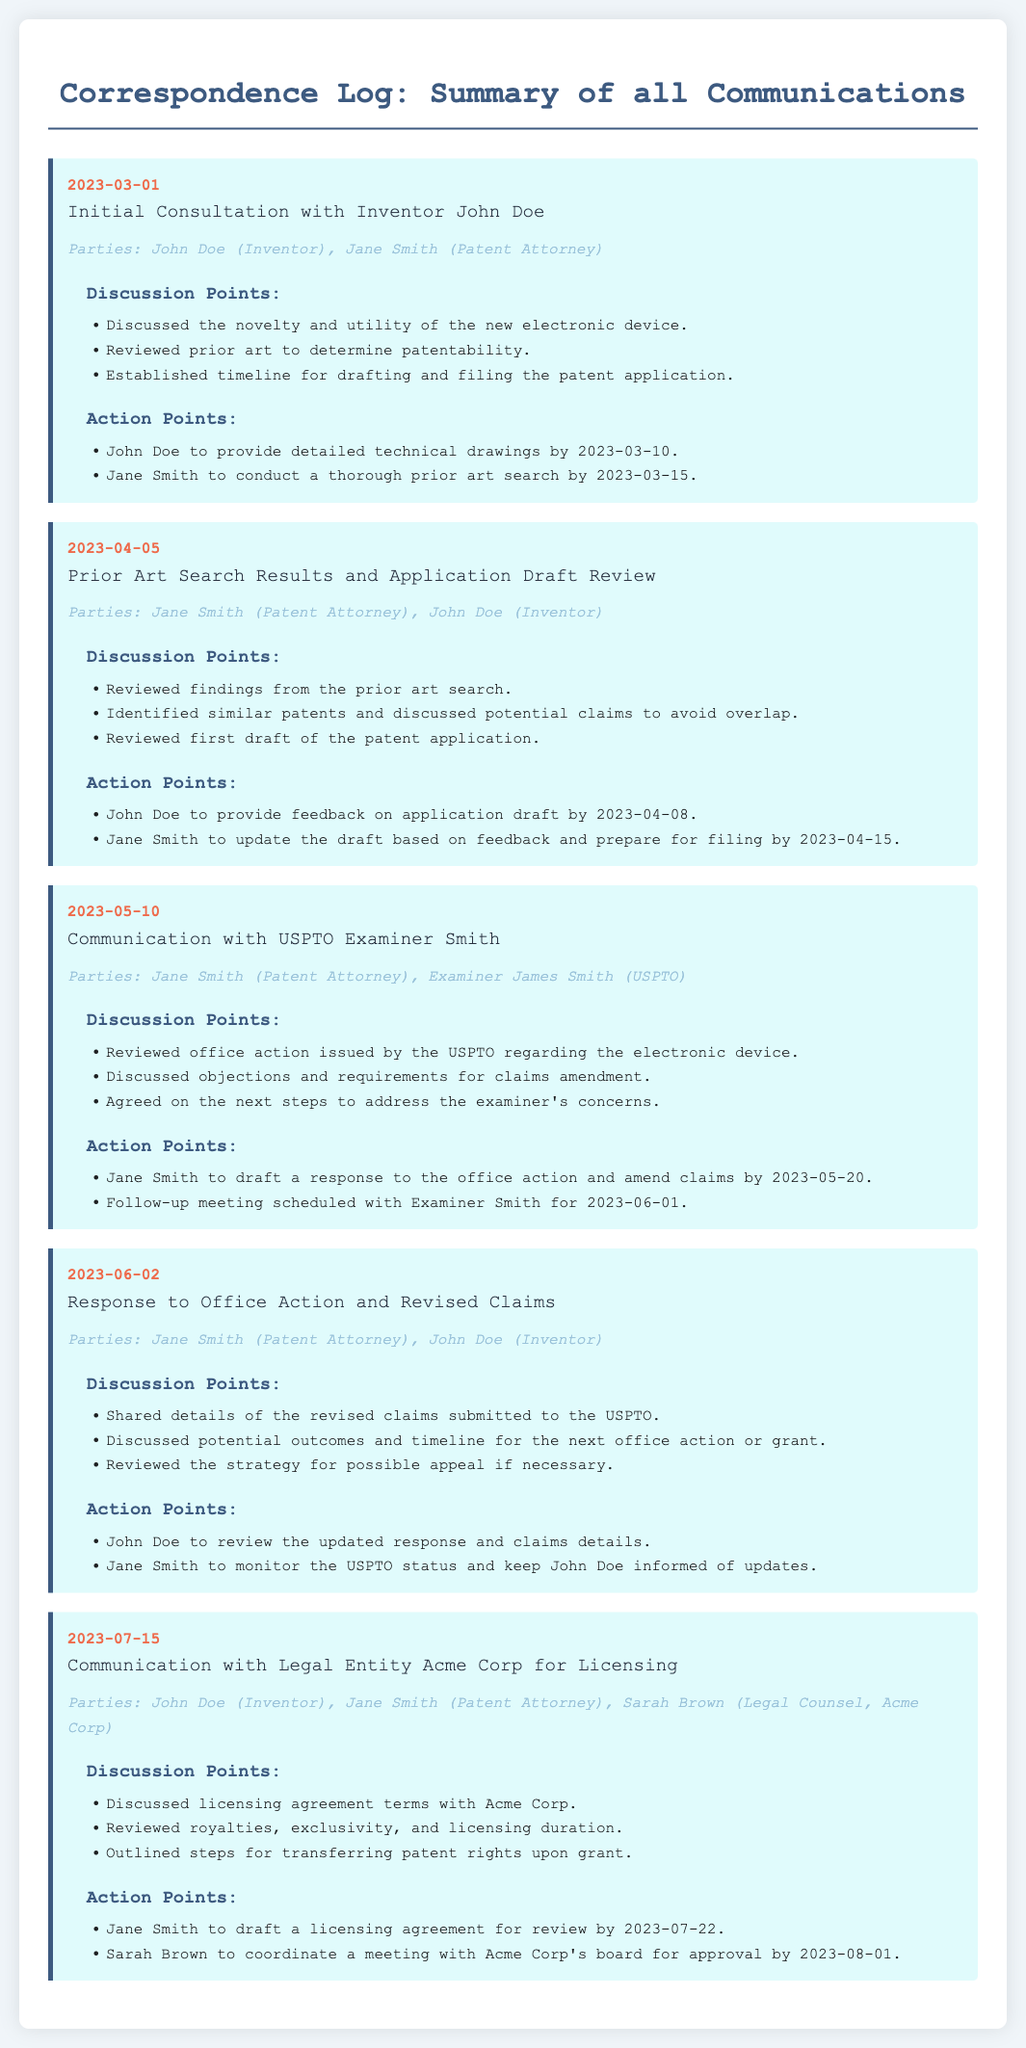what is the date of the initial consultation? The initial consultation with inventor John Doe took place on March 1, 2023.
Answer: March 1, 2023 who is the patent attorney associated with John Doe? Jane Smith is the patent attorney who communicated with inventor John Doe.
Answer: Jane Smith what was discussed during the meeting on April 5, 2023? During the April 5, 2023 meeting, the findings from the prior art search and the first draft of the patent application were discussed.
Answer: Prior art search results what action is John Doe required to complete by April 8, 2023? John Doe is required to provide feedback on the application draft by April 8, 2023.
Answer: Provide feedback how many parties were involved in the communication with Acme Corp? The communication with Acme Corp involved three parties: John Doe, Jane Smith, and Sarah Brown.
Answer: Three parties what is the action point for Jane Smith after the office action response on June 2, 2023? Jane Smith needs to monitor the USPTO status and keep John Doe informed.
Answer: Monitor USPTO status on what date is the follow-up meeting with Examiner Smith scheduled? The follow-up meeting with Examiner Smith is scheduled for June 1, 2023.
Answer: June 1, 2023 what type of agreement was discussed with Acme Corp on July 15, 2023? A licensing agreement was discussed with Acme Corp on July 15, 2023.
Answer: Licensing agreement which examiner communicated with Jane Smith on May 10, 2023? The examiner who communicated with Jane Smith is James Smith.
Answer: James Smith 